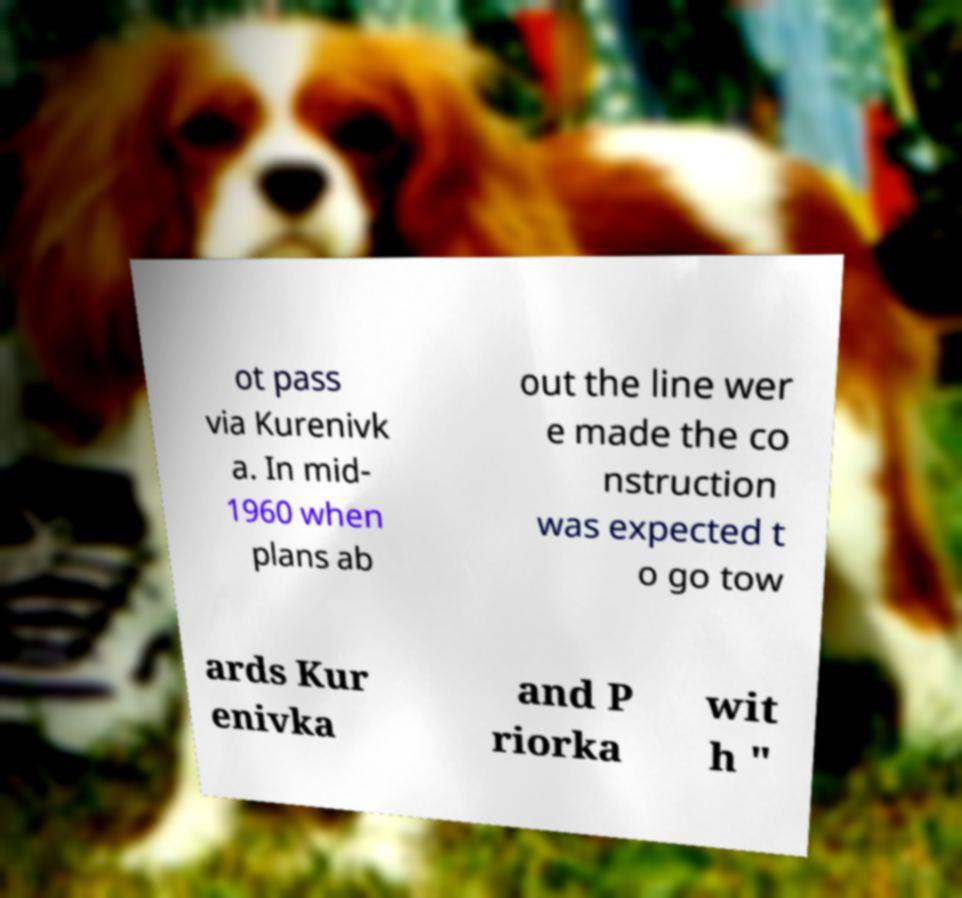What messages or text are displayed in this image? I need them in a readable, typed format. ot pass via Kurenivk a. In mid- 1960 when plans ab out the line wer e made the co nstruction was expected t o go tow ards Kur enivka and P riorka wit h " 